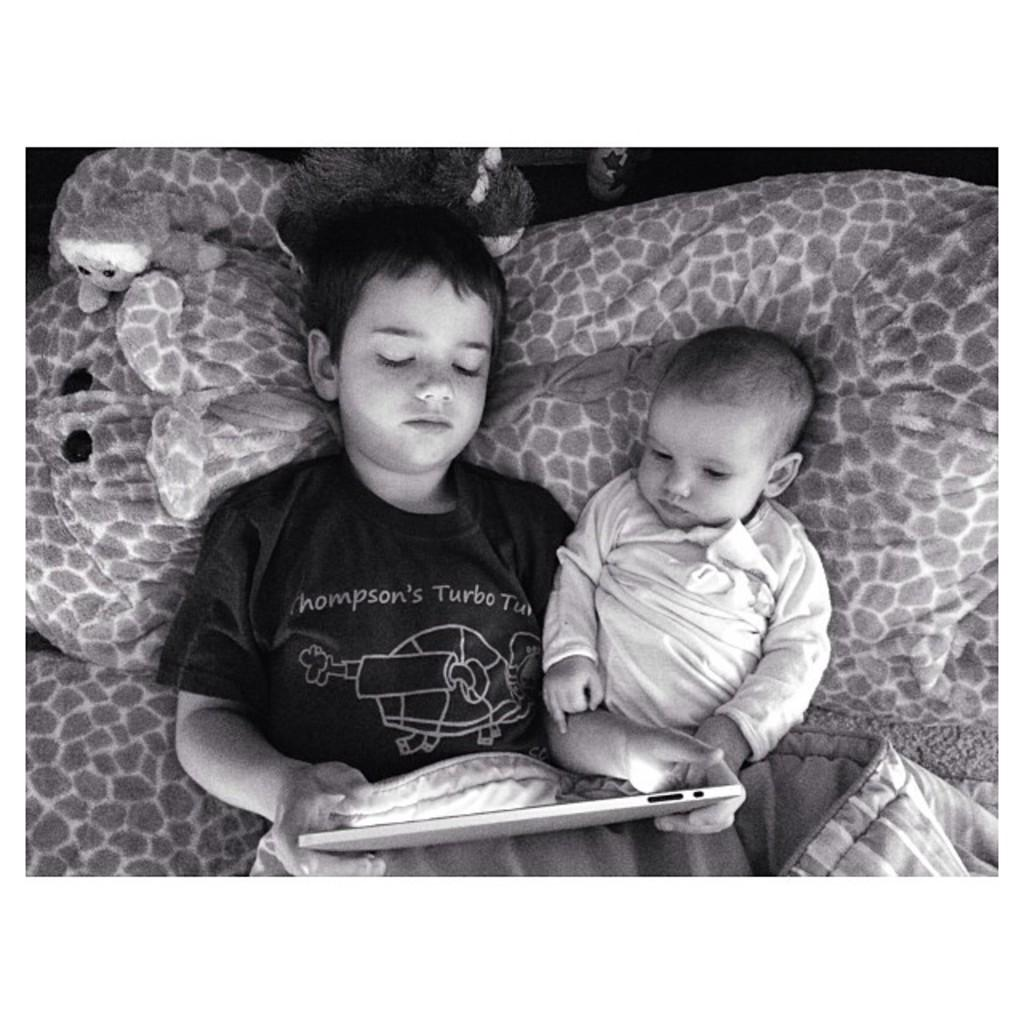How many kids are in the image? There are two kids in the image. What are the kids doing in the image? The kids are lying on a bed. What is one of the kids holding? One of the kids is holding an iPad. What else can be seen around the kids? There are dolls around the kids. What type of ear is visible on the kids in the image? There is no specific ear visible on the kids in the image; they are not shown in a way that highlights their ears. 